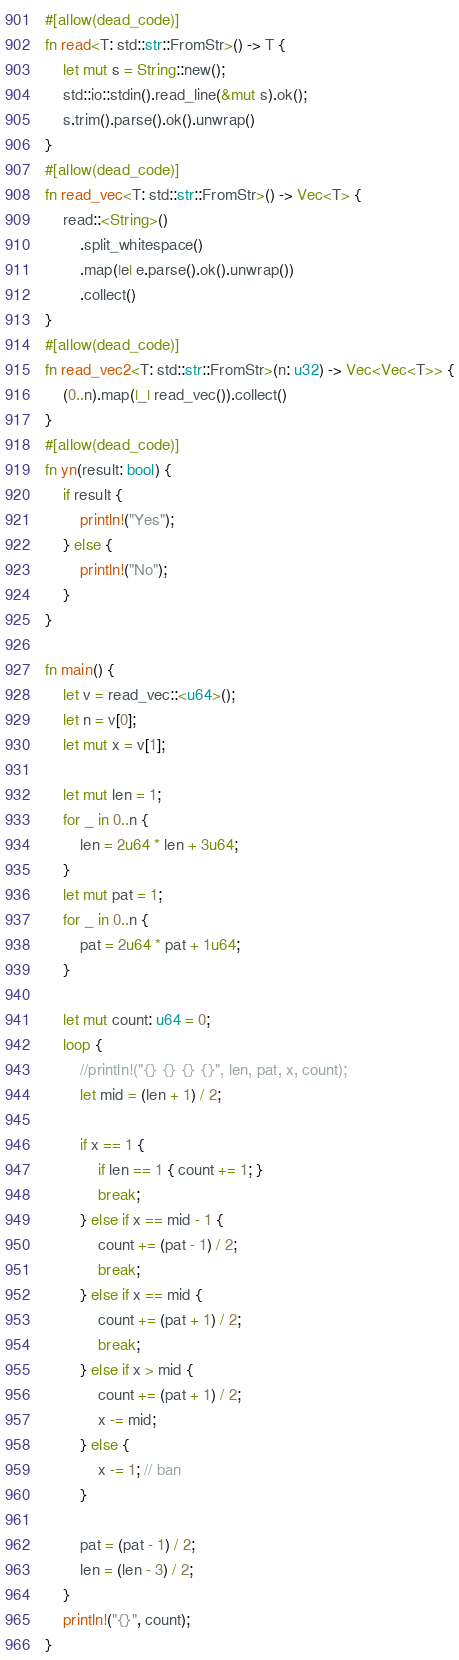Convert code to text. <code><loc_0><loc_0><loc_500><loc_500><_Rust_>#[allow(dead_code)]
fn read<T: std::str::FromStr>() -> T {
    let mut s = String::new();
    std::io::stdin().read_line(&mut s).ok();
    s.trim().parse().ok().unwrap()
}
#[allow(dead_code)]
fn read_vec<T: std::str::FromStr>() -> Vec<T> {
    read::<String>()
        .split_whitespace()
        .map(|e| e.parse().ok().unwrap())
        .collect()
}
#[allow(dead_code)]
fn read_vec2<T: std::str::FromStr>(n: u32) -> Vec<Vec<T>> {
    (0..n).map(|_| read_vec()).collect()
}
#[allow(dead_code)]
fn yn(result: bool) {
    if result {
        println!("Yes");
    } else {
        println!("No");
    }
}

fn main() {
    let v = read_vec::<u64>();
    let n = v[0];
    let mut x = v[1];

    let mut len = 1;
    for _ in 0..n {
        len = 2u64 * len + 3u64;
    }
    let mut pat = 1;
    for _ in 0..n {
        pat = 2u64 * pat + 1u64;
    }

    let mut count: u64 = 0;
    loop {
        //println!("{} {} {} {}", len, pat, x, count);
        let mid = (len + 1) / 2;

        if x == 1 {
            if len == 1 { count += 1; }
            break;
        } else if x == mid - 1 {
            count += (pat - 1) / 2;
            break;
        } else if x == mid {
            count += (pat + 1) / 2;
            break;
        } else if x > mid {
            count += (pat + 1) / 2;
            x -= mid;
        } else {
            x -= 1; // ban
        }

        pat = (pat - 1) / 2;
        len = (len - 3) / 2;
    }
    println!("{}", count);
}
</code> 